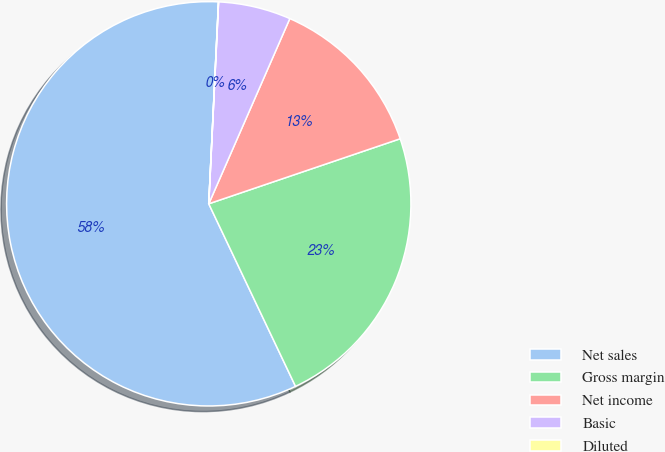Convert chart to OTSL. <chart><loc_0><loc_0><loc_500><loc_500><pie_chart><fcel>Net sales<fcel>Gross margin<fcel>Net income<fcel>Basic<fcel>Diluted<nl><fcel>57.82%<fcel>23.15%<fcel>13.22%<fcel>5.79%<fcel>0.01%<nl></chart> 